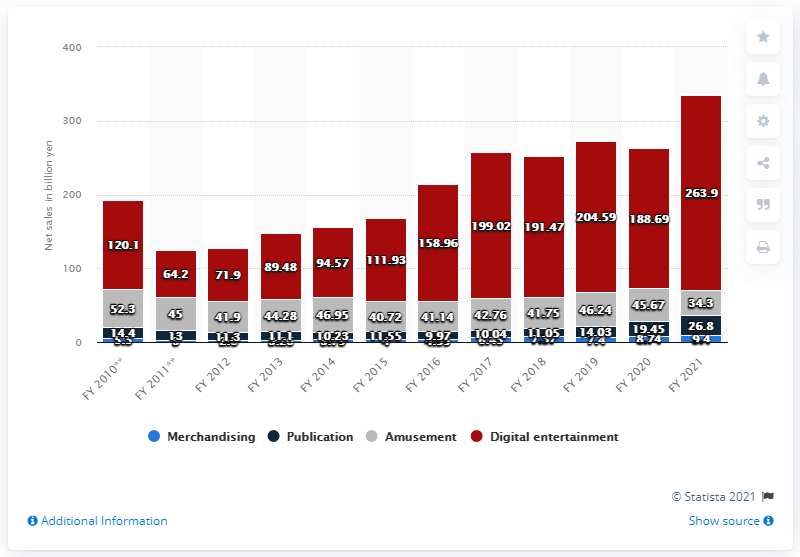Point out several critical features in this image. Square Enix's revenues are primarily generated by digital entertainment. In 2021, Square Enix's net sales were 263.9 billion yen. 